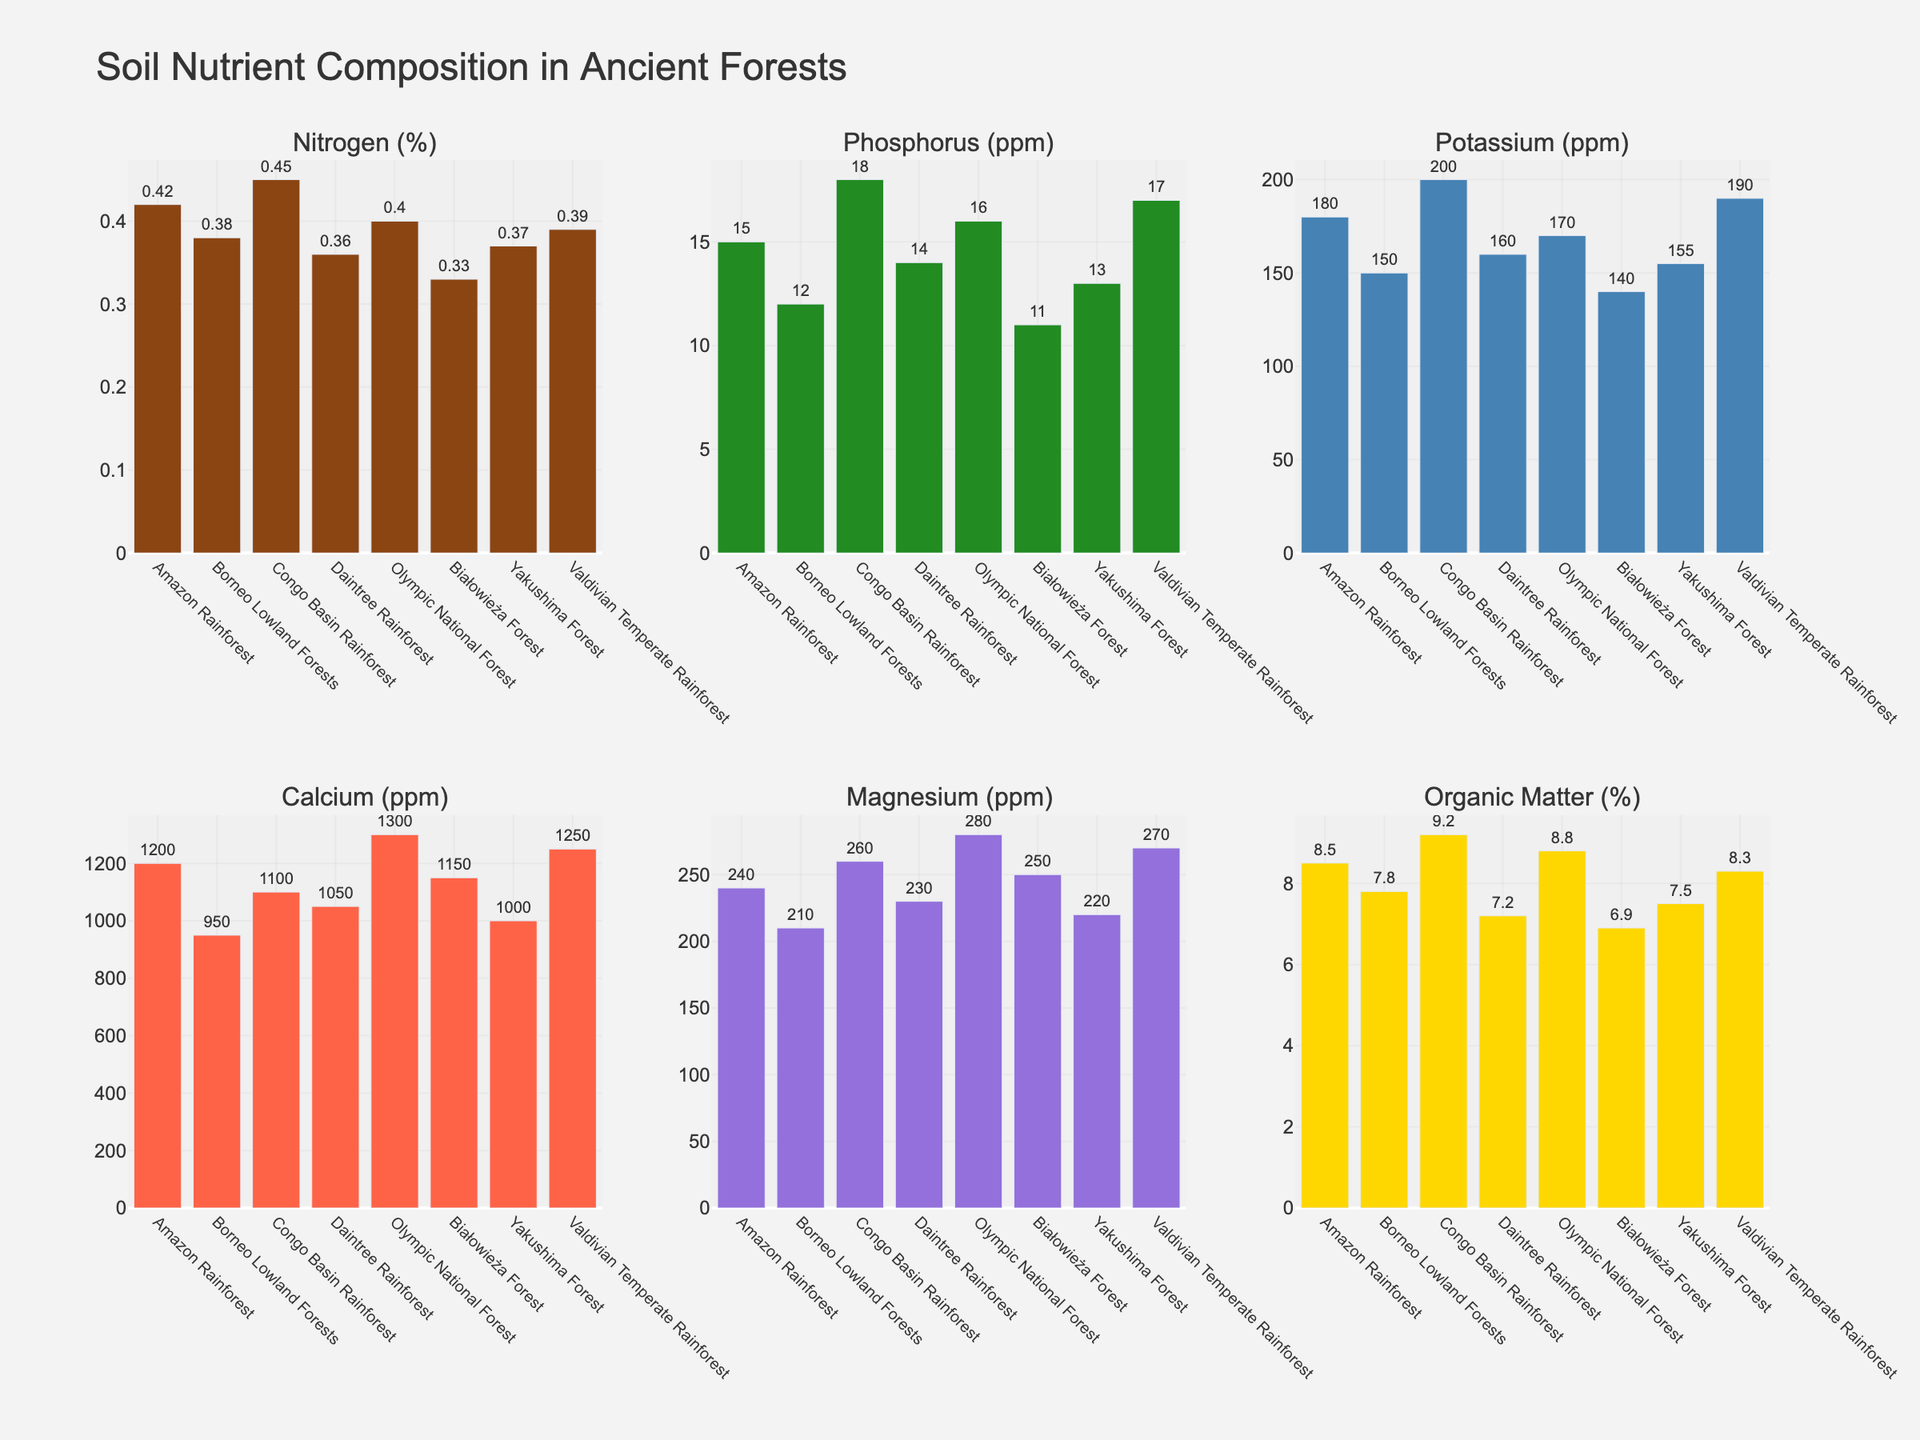Which continent has the highest nitrogen content in its soil? By examining the bar representing nitrogen content across all continents, we can identify the highest bar. The Congo Basin Rainforest has the highest nitrogen content.
Answer: Congo Basin Rainforest Which continent has the lowest phosphorus content in its soil? By comparing the heights of the phosphorus bars, we find that the Białowieża Forest has the shortest bar, indicating the lowest phosphorus content.
Answer: Białowieża Forest How does the potassium content in the Amazon Rainforest compare to the Daintree Rainforest? By looking at the heights of the potassium bars for both the Amazon Rainforest and Daintree Rainforest, we can see that the Amazon Rainforest has a taller bar, indicating higher potassium content. Specifically, Amazon (180 ppm) vs. Daintree (160 ppm).
Answer: Amazon Rainforest has higher potassium content What's the difference in calcium content between the Olympic National Forest and Yakushima Forest? By comparing the calcium bars for Olympic National Forest and Yakushima Forest, we see that Olympic National Forest has 1300 ppm and Yakushima Forest has 1000 ppm. The difference is 1300 - 1000 = 300 ppm.
Answer: 300 ppm What is the average magnesium content across the continents? To find the average magnesium content, add the magnesium values for all continents and then divide by the number of continents. (240 + 210 + 260 + 230 + 280 + 250 + 220 + 270) / 8 = 245 ppm.
Answer: 245 ppm Which forest has the highest organic matter percentage? By comparing the heights of the organic matter bars, the Congo Basin Rainforest has the tallest bar, indicating the highest percentage of organic matter.
Answer: Congo Basin Rainforest Is the phosphorus content more variable among the forests compared to nitrogen content? To determine if phosphorus content is more variable, observe the range and differences in bar height for both phosphorus and nitrogen. The phosphorus bars show larger variations (11 to 18 ppm) compared to nitrogen bars (0.33% to 0.45%).
Answer: Yes Across the continents, is the average nitrogen content higher or lower than 0.4%? Calculate the average nitrogen content: (0.42 + 0.38 + 0.45 + 0.36 + 0.40 + 0.33 + 0.37 + 0.39) / 8 = 0.3875%. Since 0.3875% is less than 0.4%, the average is lower.
Answer: Lower Which continent has the highest calcium content and what is its value? By examining the calcium bars, the Olympic National Forest has the tallest bar indicating the highest calcium content, which is 1300 ppm.
Answer: Olympic National Forest, 1300 ppm 